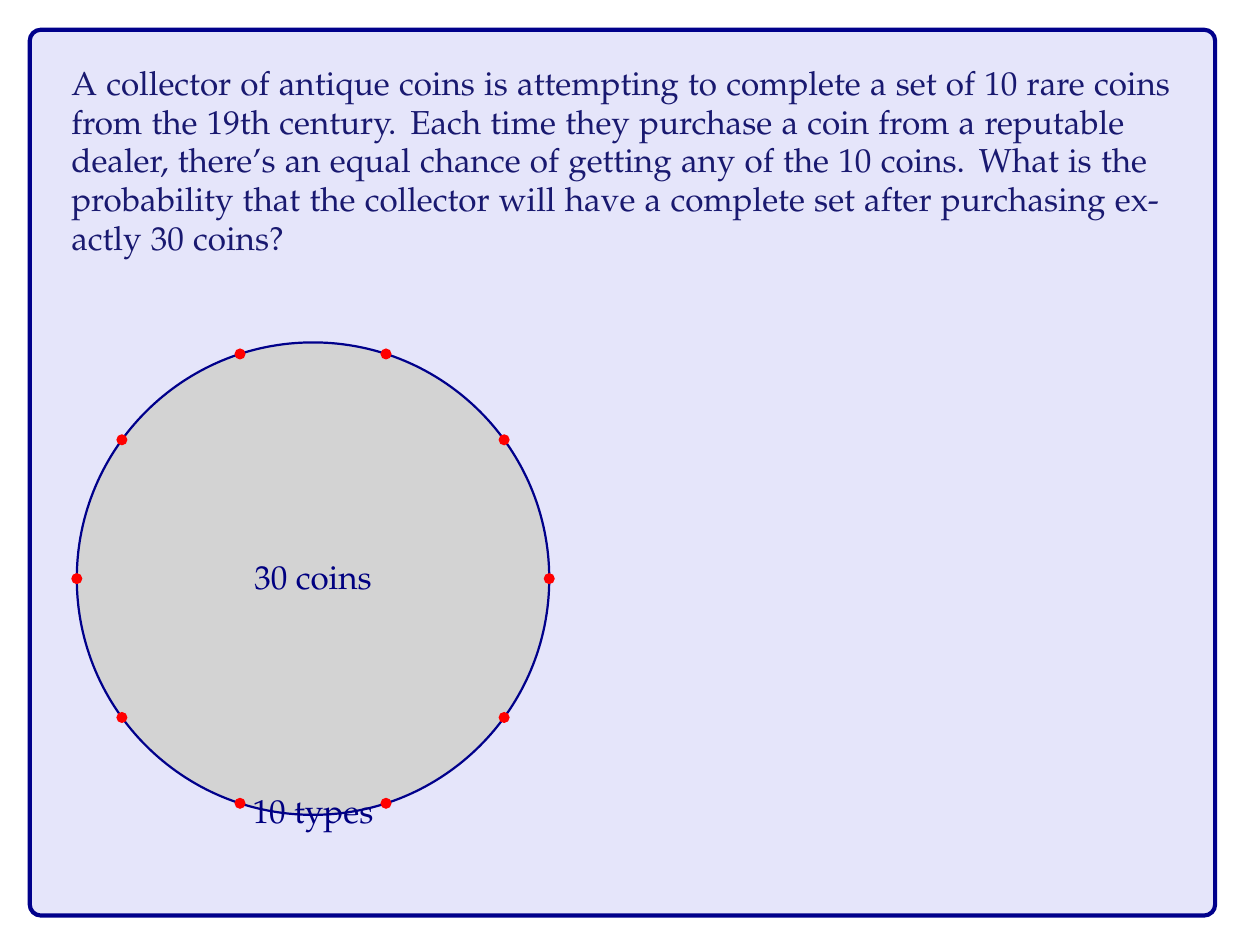Help me with this question. Let's approach this step-by-step using the concept of Sterling numbers of the second kind:

1) Let $S(n,k)$ denote the Stirling number of the second kind, which counts the number of ways to partition n distinct objects into k non-empty subsets.

2) In our case, we want all 10 types of coins to be present in the 30 coins purchased. This is equivalent to partitioning 30 distinct coins into exactly 10 non-empty subsets.

3) The total number of ways to distribute 30 coins into 10 types is $10^{30}$, as each coin has 10 choices independently.

4) The probability is thus:

   $$P(\text{complete set}) = \frac{S(30,10) \cdot 10!}{10^{30}}$$

5) The factor $10!$ is included because the order of the subsets matters in our case (each subset corresponds to a specific coin type).

6) We can calculate $S(30,10)$ using the recursive formula or a computer algebra system. Its value is approximately $1.2463 \times 10^{26}$.

7) Substituting this value:

   $$P(\text{complete set}) = \frac{1.2463 \times 10^{26} \cdot 10!}{10^{30}} \approx 0.7271$$

Thus, there is about a 72.71% chance of having a complete set after purchasing 30 coins.
Answer: $\frac{S(30,10) \cdot 10!}{10^{30}} \approx 0.7271$ 